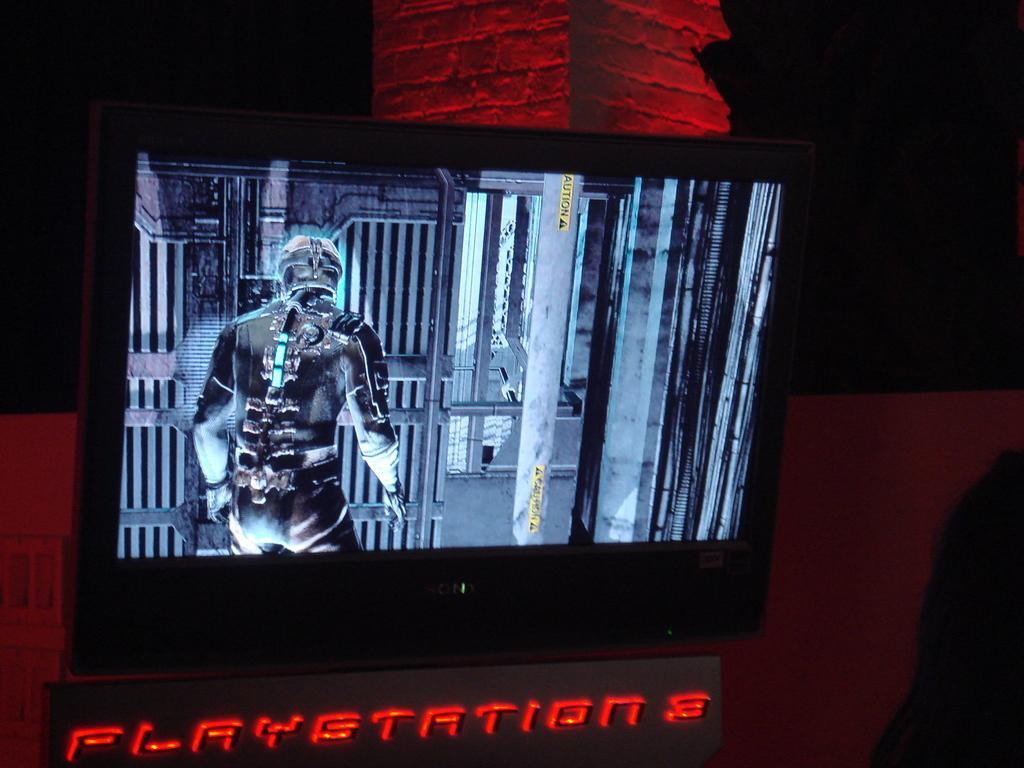How would you summarize this image in a sentence or two? In this image we can see a display screen and some animated image in it. 